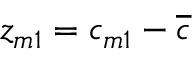<formula> <loc_0><loc_0><loc_500><loc_500>z _ { m 1 } = c _ { m 1 } - \overline { c }</formula> 